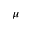Convert formula to latex. <formula><loc_0><loc_0><loc_500><loc_500>\mu</formula> 